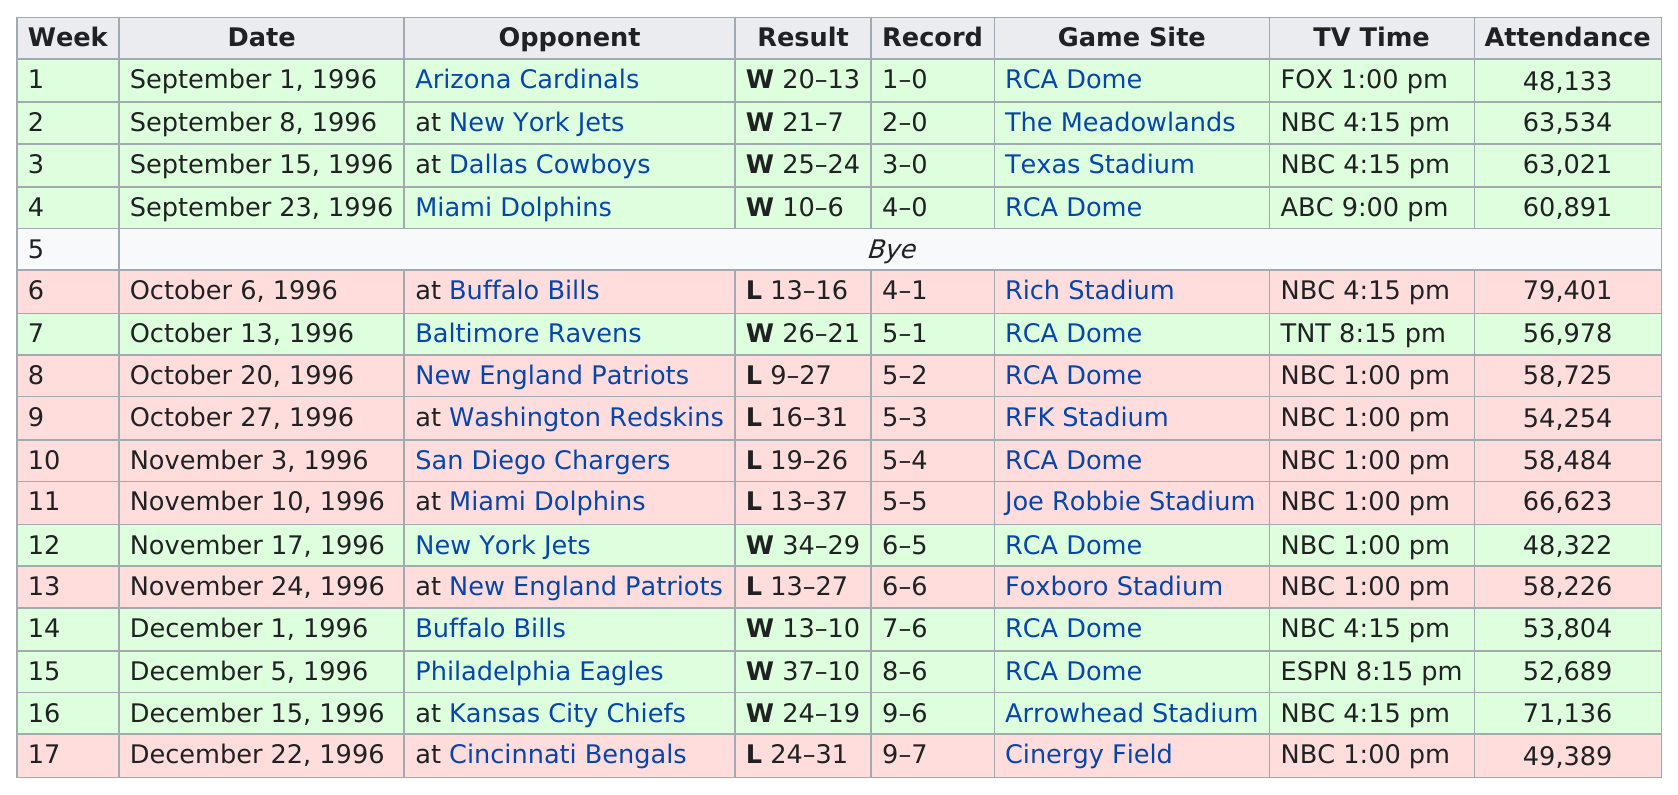Outline some significant characteristics in this image. On November 10, 1996, a game was held and 66,623 people attended. In 1996, the Indianapolis Colts called the RCA Dome their home field. The result of the last game of the regular season was a loss, with the score being 24-31. Which stadium had their highest attendance? Rich Stadium did. In the month of October, I accrued one win. 